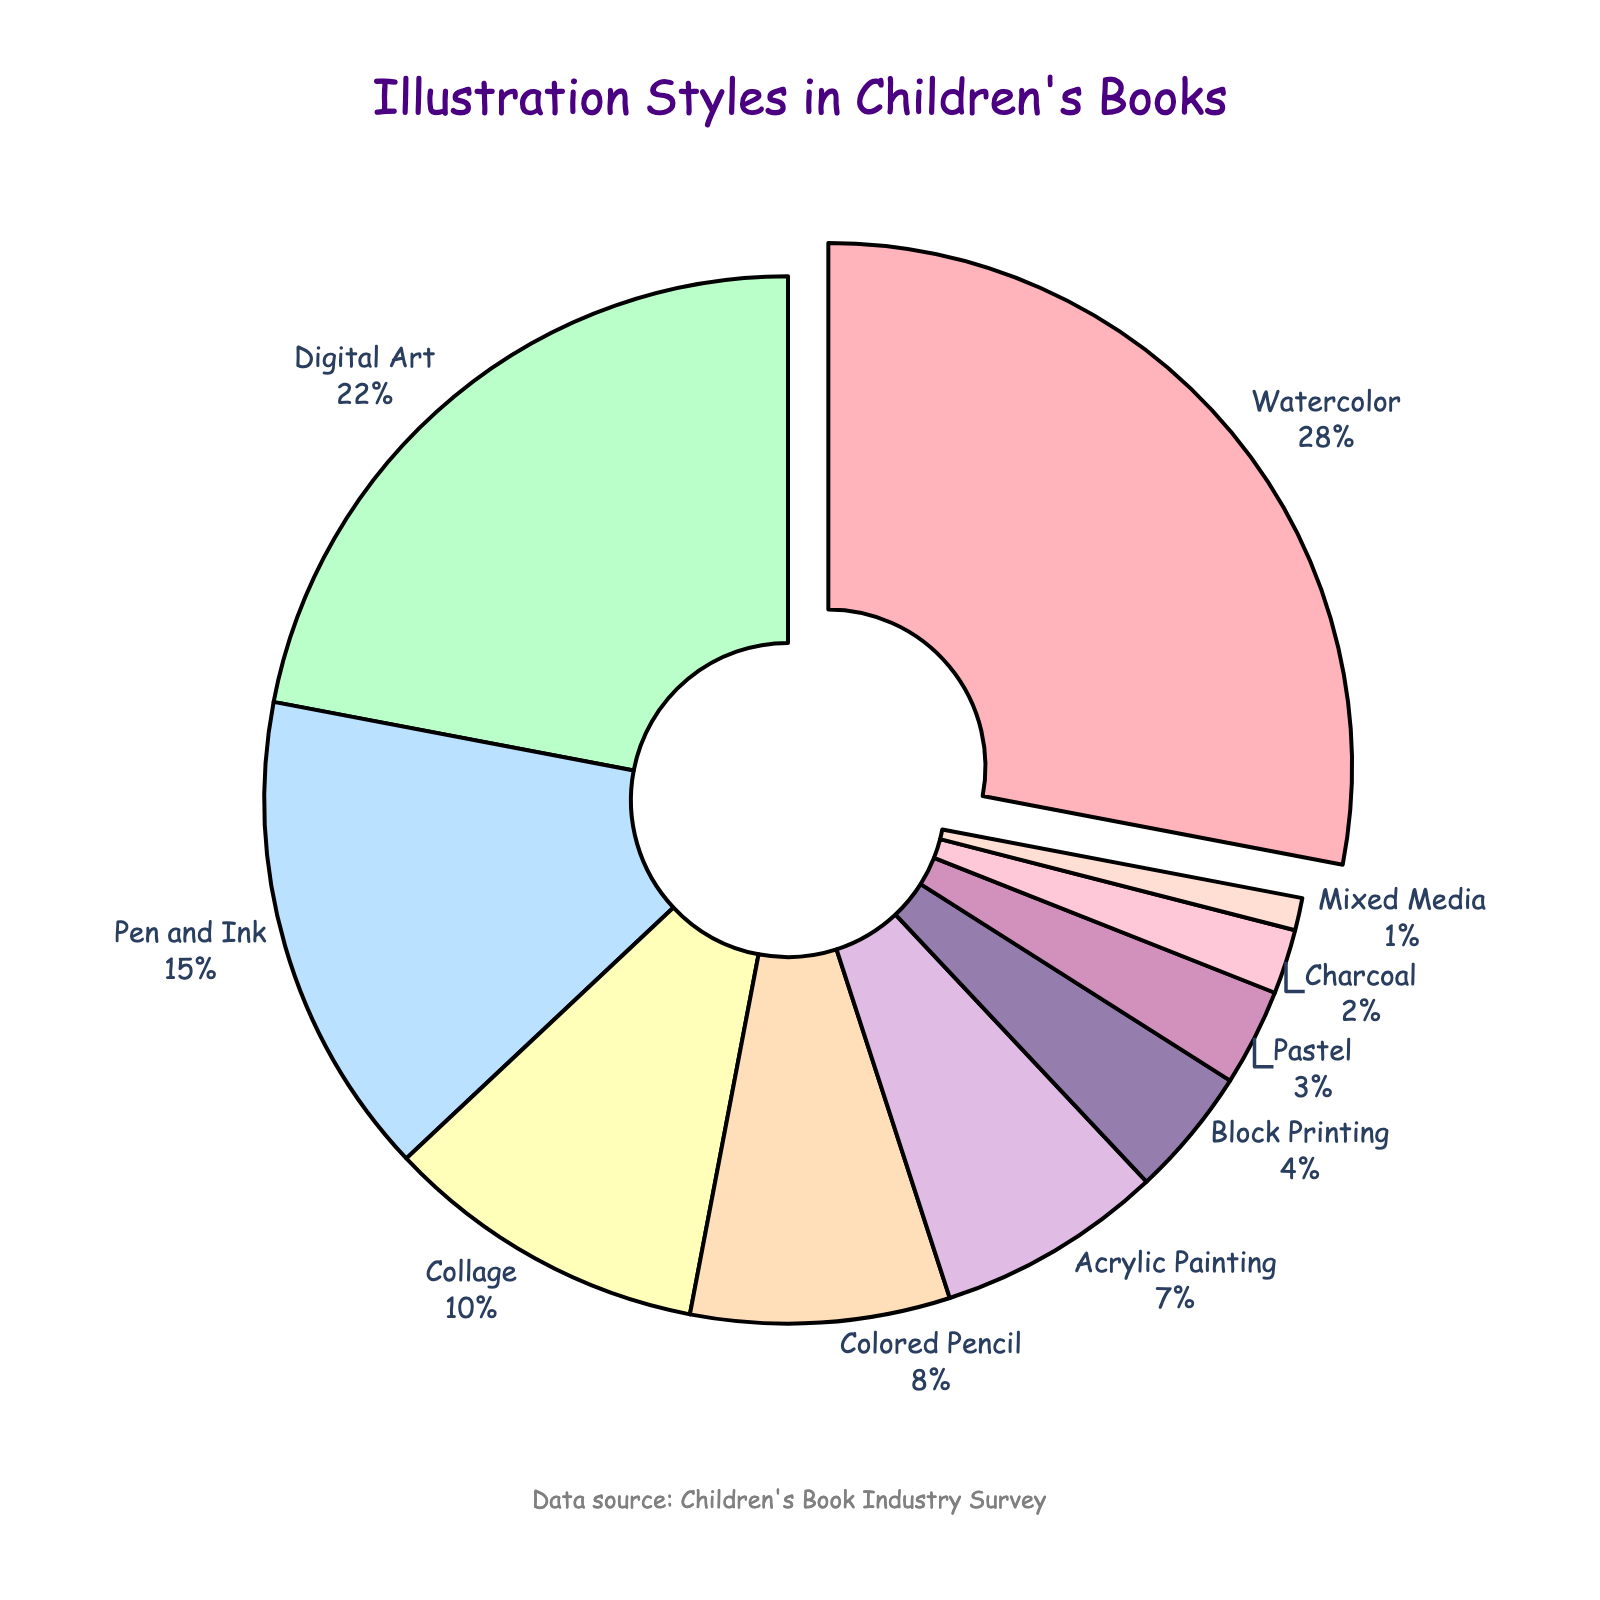What illustration style is used the most in children’s books? Looking at the pie chart, the segment with the largest size and is pulled out slightly from the rest indicates the most used style. Watercolor has the largest segment.
Answer: Watercolor Which illustration style has the smallest percentage? Checking the pie chart for the smallest segment reveals the style with the smallest percentage. The smallest segment belongs to Mixed Media.
Answer: Mixed Media How much more popular is Watercolor compared to Charcoal? The percentages for Watercolor and Charcoal are 28% and 2%, respectively. The difference is 28% - 2% = 26%.
Answer: 26% What is the combined percentage of Pen and Ink, Colored Pencil, and Acrylic Painting? Adding the percentages of Pen and Ink (15%), Colored Pencil (8%), and Acrylic Painting (7%) gives us 15% + 8% + 7% = 30%.
Answer: 30% Is Digital Art more popular than Collage in children's book illustrations? Looking at the percentages, Digital Art is 22% while Collage is 10%, which indicates Digital Art is more popular.
Answer: Yes Which illustration methods have an equal or smaller percentage compared to Pastel? Pastel has 3%. The styles with equal or smaller percentages are Pastel (3%), Charcoal (2%), and Mixed Media (1%).
Answer: Pastel, Charcoal, Mixed Media What percentage of illustration styles does not use traditional art mediums (like Watercolor, Acrylic, etc.)? Digital Art is 22%, since all other styles (except for this) are considered traditional.
Answer: 22% List the illustration styles that make up more than 10% of the total. The pie chart segments larger than 10% are Watercolor (28%), Digital Art (22%), and Pen and Ink (15%).
Answer: Watercolor, Digital Art, Pen and Ink What is the total percentage of styles involving paint (Watercolor, Acrylic Painting)? Adding the percentages of Watercolor (28%) and Acrylic Painting (7%) gives 28% + 7% = 35%.
Answer: 35% 